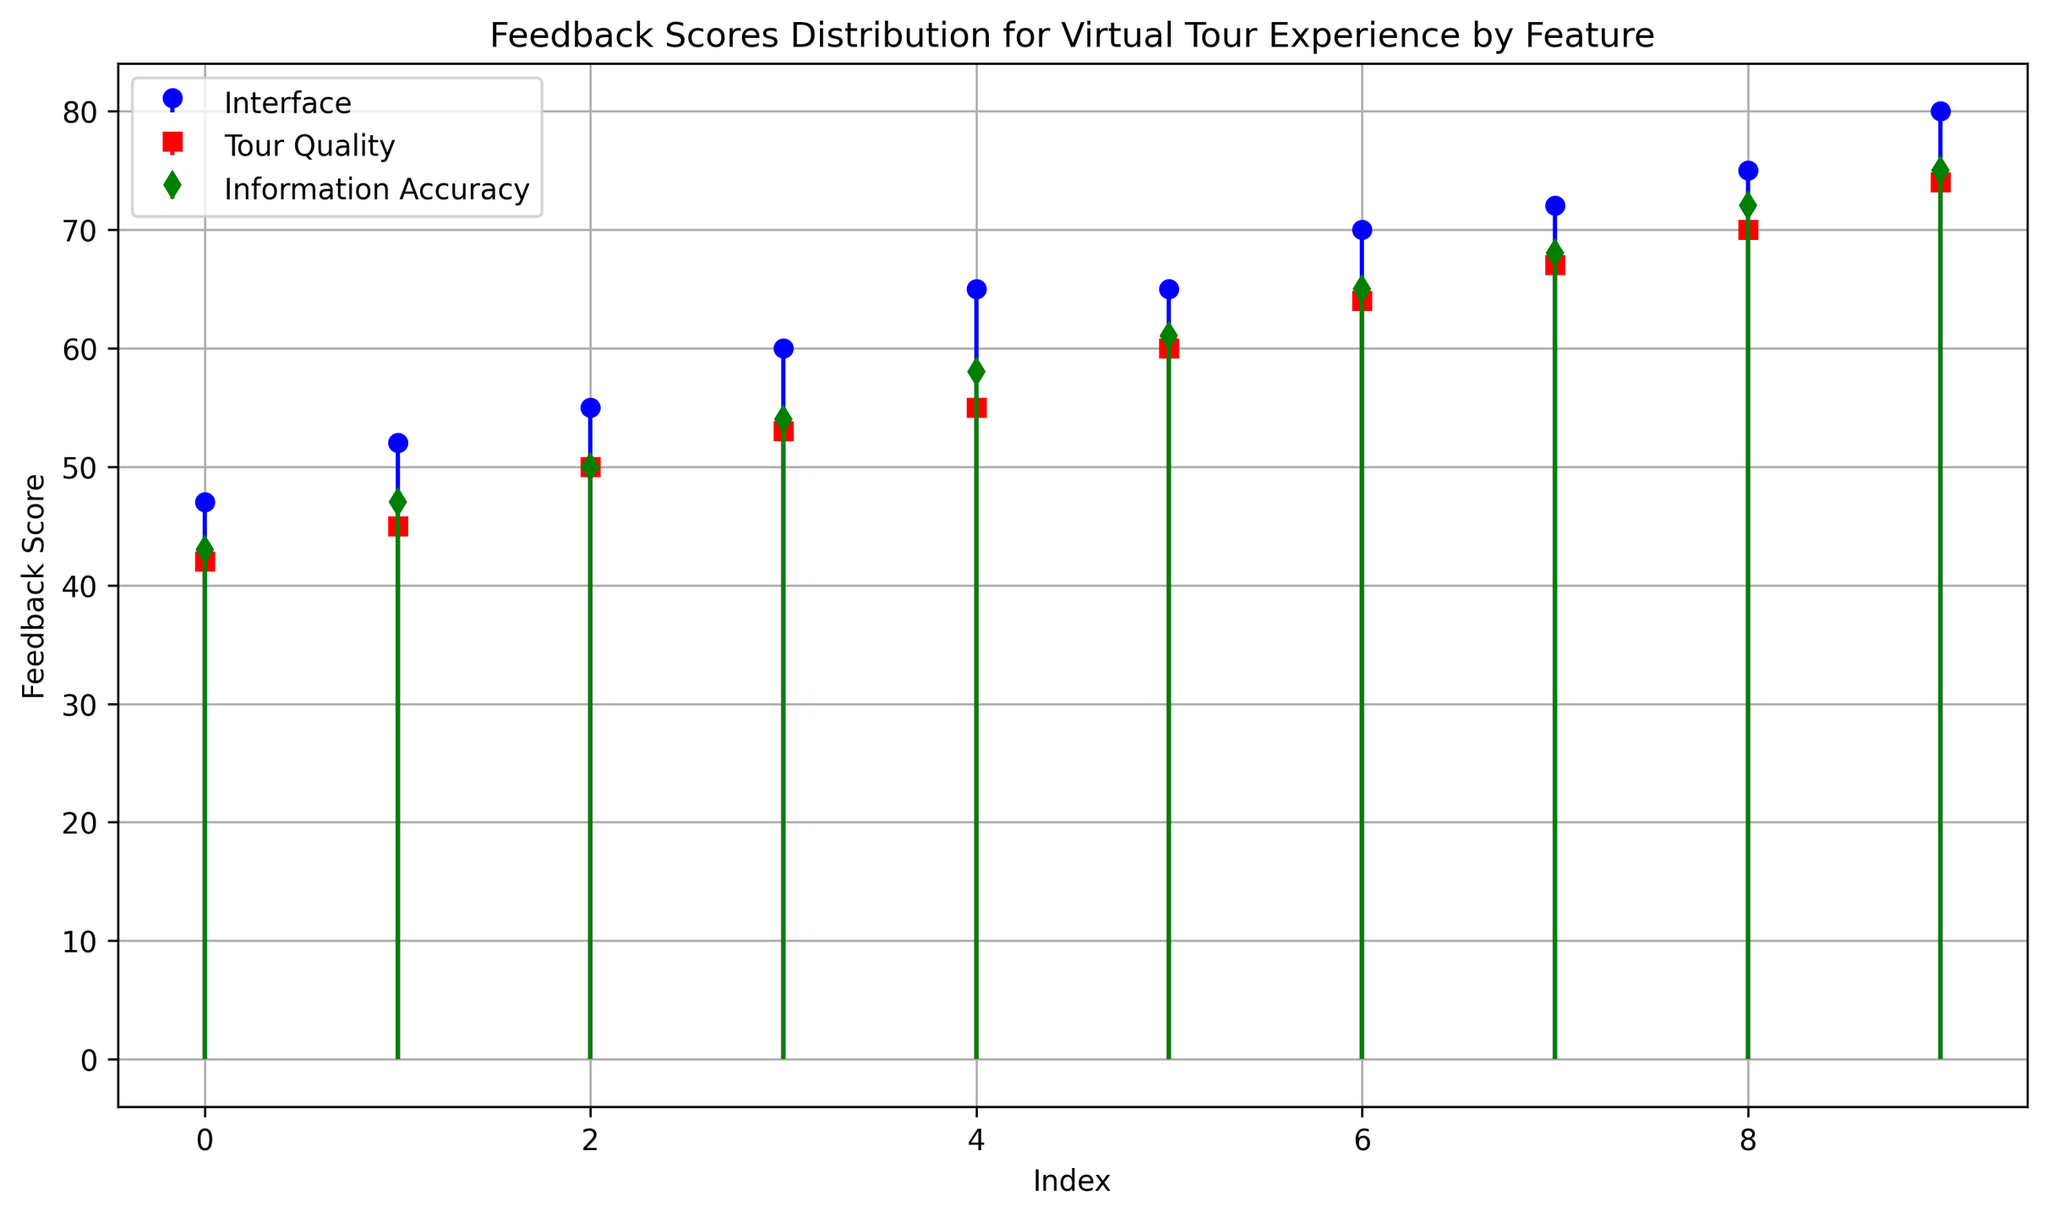What is the range of feedback scores for the Interface feature? The range is calculated by subtracting the minimum score from the maximum score. For Interface, the minimum score is 47 and the maximum score is 80, so the range is 80 - 47 = 33.
Answer: 33 Which feature has the highest median feedback score? Median is the middle value when scores are ordered. For Interface: (47, 52, 55, 60, 65, 65, 70, 72, 75, 80), median = (65+65)/2 = 65. For Tour Quality: (42, 45, 50, 53, 55, 60, 64, 67, 70, 74), median = (55+60)/2 = 57.5. For Information Accuracy: (43, 47, 50, 54, 58, 61, 65, 68, 72, 75), median = (58+61)/2 = 59.5. Comparing the medians, Information Accuracy has the highest median of 59.5.
Answer: Information Accuracy Which feature exhibits the most variation in feedback scores? Variation can be assessed by the spread of the stem heights. The Interface feature shows scores from 47 to 80, Tour Quality from 42 to 74, and Information Accuracy from 43 to 75. Interface has the widest range (80-47=33).
Answer: Interface Are there any feedback scores that appear in all three features? We must check if there is any common score in Interface, Tour Quality, and Information Accuracy. By examining the stem plot, no single feedback score is shared among all three features.
Answer: No Which feature has the highest single feedback score? The highest single feedback score can be observed from the stems. Interface has a score of 80, which is higher than the highest scores of Tour Quality (74) and Information Accuracy (75). Therefore, Interface has the highest single feedback score.
Answer: Interface How does the average feedback score of Tour Quality compare to Information Accuracy? To find the average feedback score of each feature, sum their scores and divide by the number of scores. Tour Quality: (42 + 45 + 50 + 53 + 55 + 60 + 64 + 67 + 70 + 74) / 10 = 58. Information Accuracy: (43 + 47 + 50 + 54 + 58 + 61 + 65 + 68 + 72 + 75) / 10 = 59. The average score of Information Accuracy is slightly higher than Tour Quality.
Answer: Information Accuracy is higher Which feature shows the least overlap with the others in terms of feedback scores? Overlap refers to shared scores among features. By examining the ranges, Interface (47-80), Tour Quality (42-74), and Information Accuracy (43-75), we see there’s a less significant overlap between Tour Quality and the other features in terms of shared scores.
Answer: Tour Quality What is the feedback score trend for Interface and how does it compare to Tour Quality? For Interface, the scores range between 47 to 80 and for Tour Quality between 42 to 74. Interface shows a higher general trend in feedback scores, as indicated by multiple scores above 70. By observing the visual trend line formed by the stems, Interface generally has higher scores.
Answer: Interface is higher 